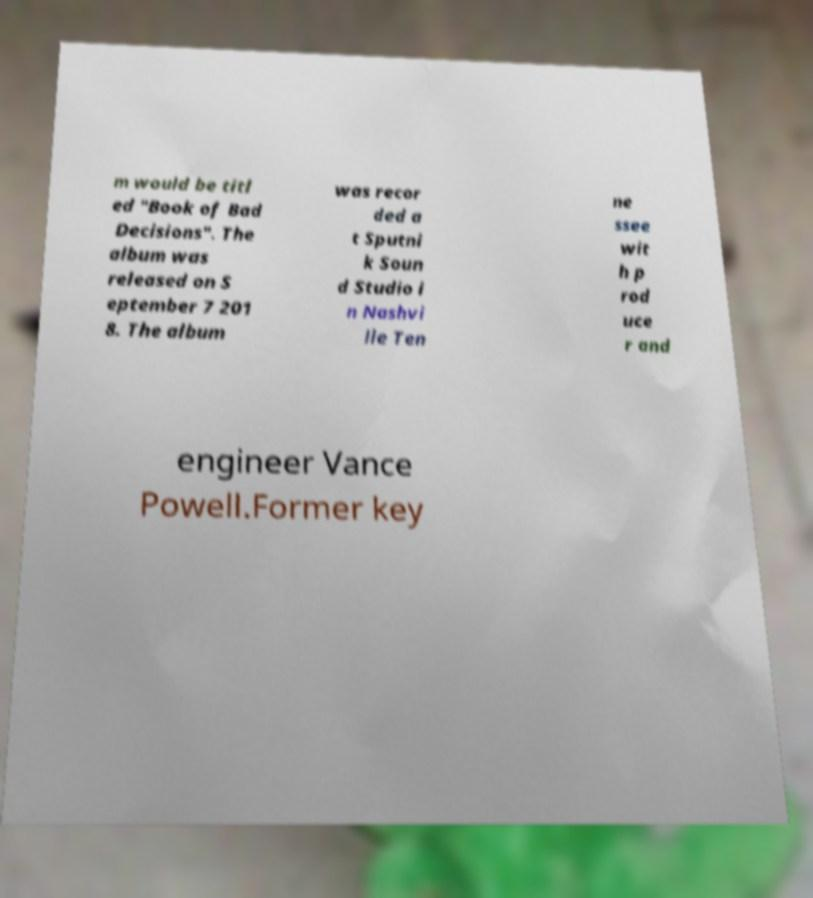Could you extract and type out the text from this image? m would be titl ed "Book of Bad Decisions". The album was released on S eptember 7 201 8. The album was recor ded a t Sputni k Soun d Studio i n Nashvi lle Ten ne ssee wit h p rod uce r and engineer Vance Powell.Former key 